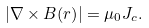<formula> <loc_0><loc_0><loc_500><loc_500>| \nabla \times { B ( r ) } | = \mu _ { 0 } J _ { c } .</formula> 